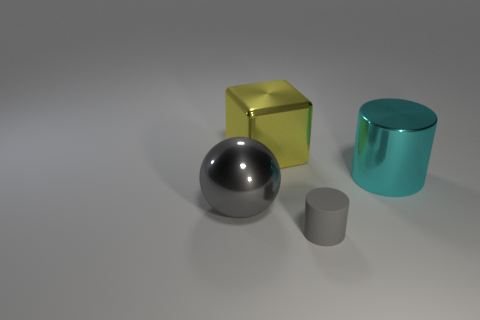Subtract all green balls. Subtract all brown cubes. How many balls are left? 1 Add 4 big purple blocks. How many objects exist? 8 Subtract all cubes. How many objects are left? 3 Add 4 big gray metallic spheres. How many big gray metallic spheres are left? 5 Add 3 matte things. How many matte things exist? 4 Subtract 0 green cubes. How many objects are left? 4 Subtract all big cyan shiny cylinders. Subtract all cyan metallic things. How many objects are left? 2 